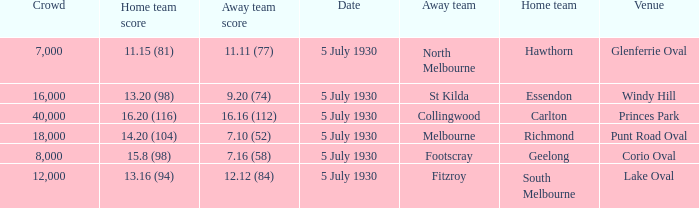Who is the away side at corio oval? Footscray. 